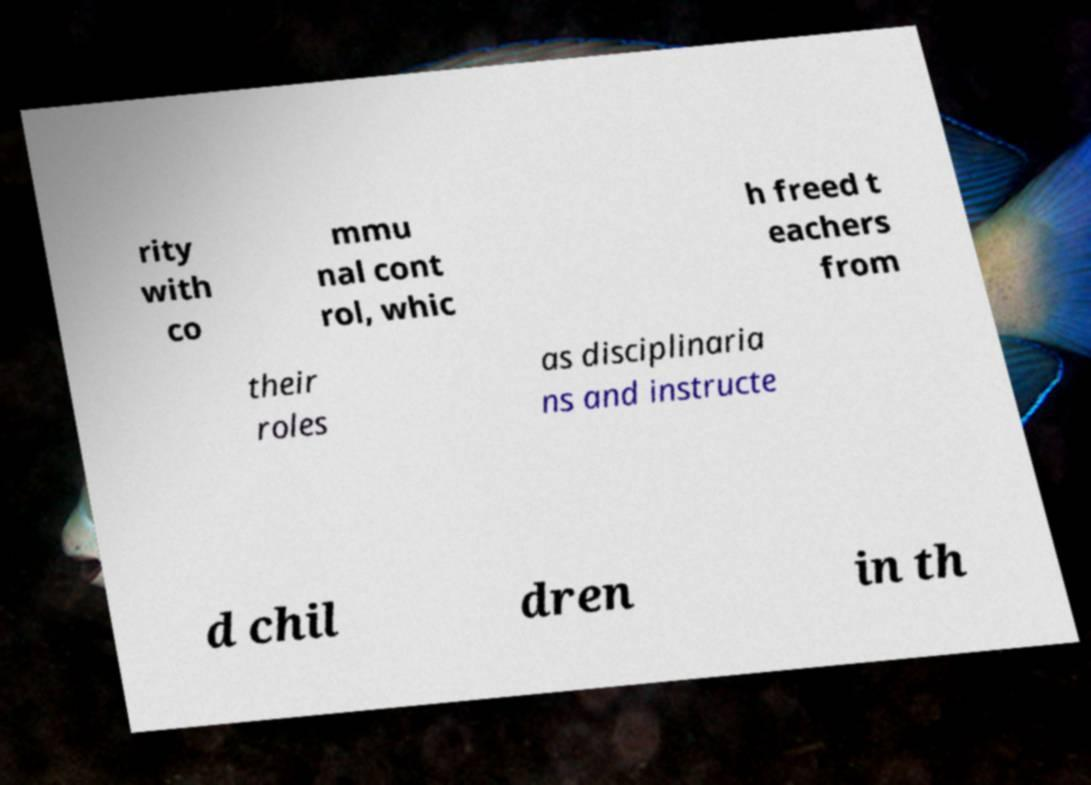Could you assist in decoding the text presented in this image and type it out clearly? rity with co mmu nal cont rol, whic h freed t eachers from their roles as disciplinaria ns and instructe d chil dren in th 